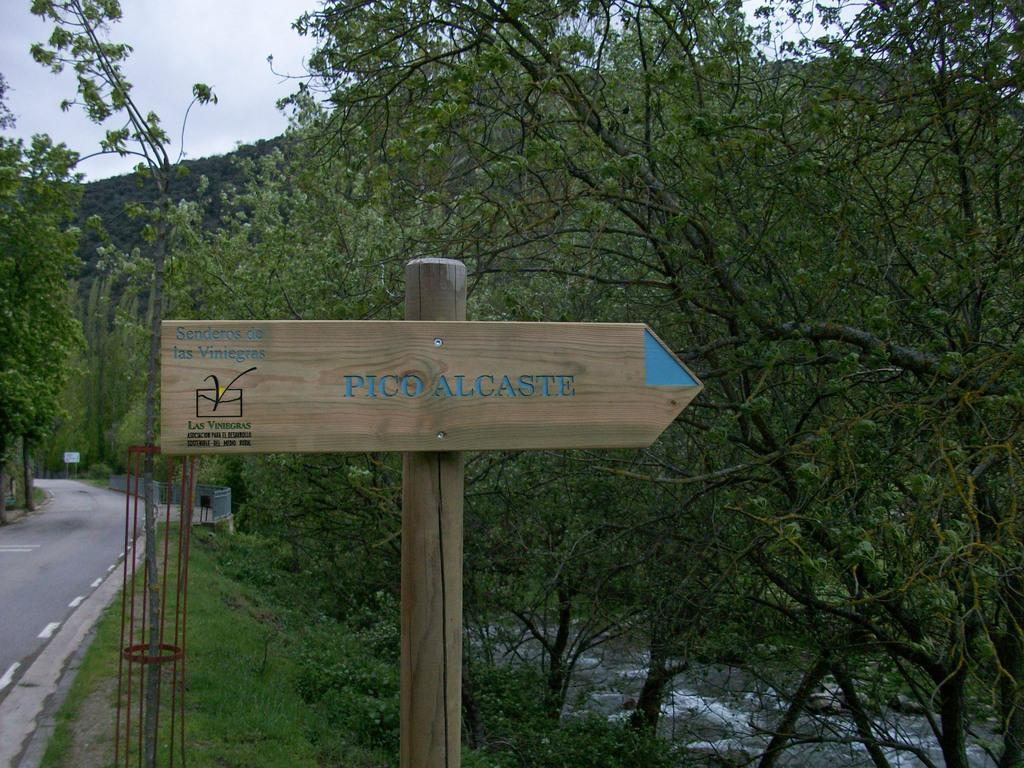What type of pathway is visible in the image? There is a road in the image. What other object can be seen in the image? There is a board in the image. What type of vegetation is present in the image? There are trees in the image. What is visible in the background of the image? The sky is visible in the image. Can you tell me how many pairs of jeans are hanging on the trees in the image? There are no jeans present in the image; it features a road, a board, trees, and the sky. What type of road is shaking in the image? There is no road shaking in the image; the road is stationary. 